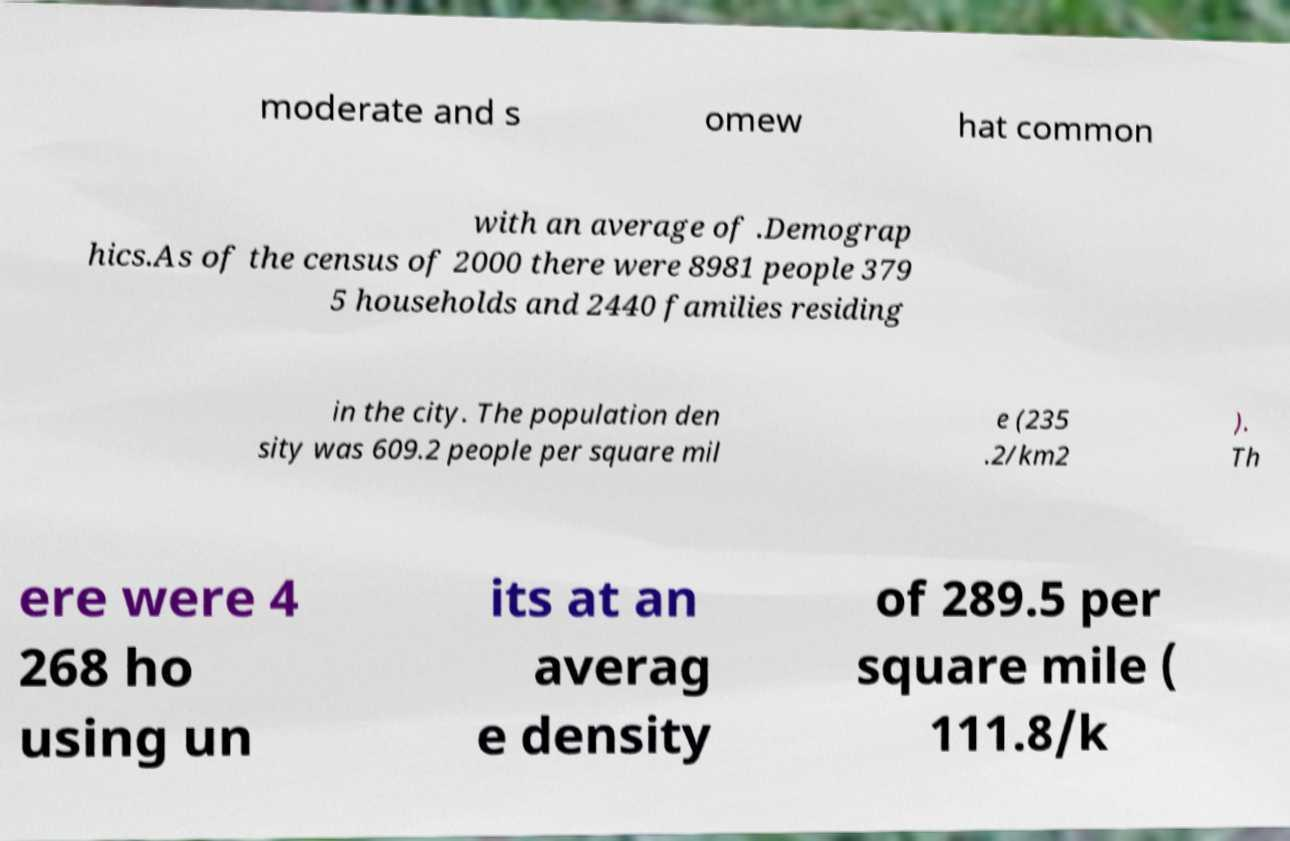Can you accurately transcribe the text from the provided image for me? moderate and s omew hat common with an average of .Demograp hics.As of the census of 2000 there were 8981 people 379 5 households and 2440 families residing in the city. The population den sity was 609.2 people per square mil e (235 .2/km2 ). Th ere were 4 268 ho using un its at an averag e density of 289.5 per square mile ( 111.8/k 